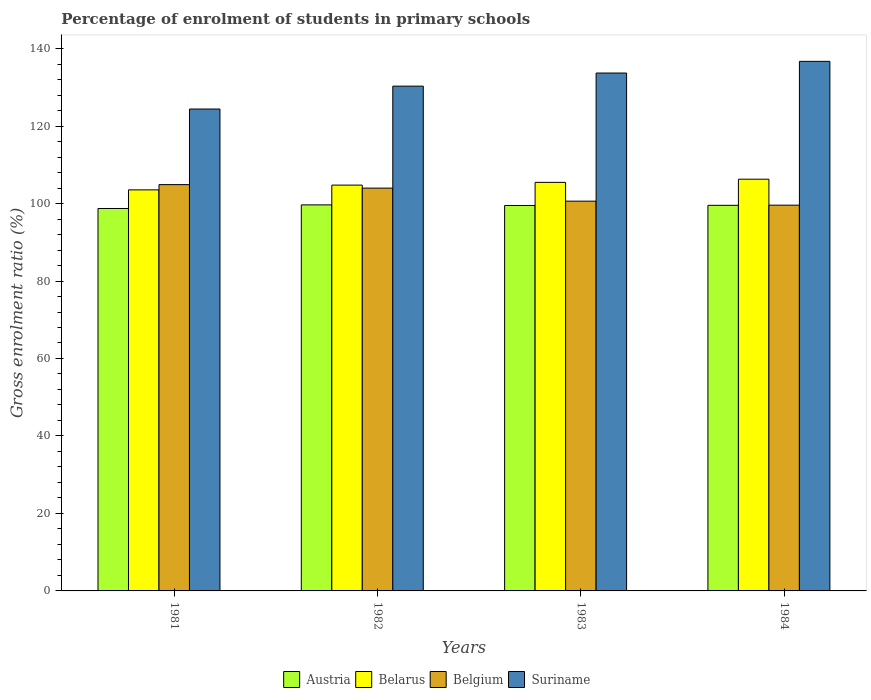How many groups of bars are there?
Your answer should be very brief. 4. Are the number of bars per tick equal to the number of legend labels?
Keep it short and to the point. Yes. How many bars are there on the 4th tick from the right?
Offer a very short reply. 4. In how many cases, is the number of bars for a given year not equal to the number of legend labels?
Your answer should be compact. 0. What is the percentage of students enrolled in primary schools in Austria in 1982?
Offer a very short reply. 99.66. Across all years, what is the maximum percentage of students enrolled in primary schools in Austria?
Make the answer very short. 99.66. Across all years, what is the minimum percentage of students enrolled in primary schools in Austria?
Offer a very short reply. 98.72. In which year was the percentage of students enrolled in primary schools in Austria minimum?
Provide a succinct answer. 1981. What is the total percentage of students enrolled in primary schools in Suriname in the graph?
Give a very brief answer. 525.09. What is the difference between the percentage of students enrolled in primary schools in Belarus in 1983 and that in 1984?
Your answer should be compact. -0.82. What is the difference between the percentage of students enrolled in primary schools in Belarus in 1982 and the percentage of students enrolled in primary schools in Austria in 1984?
Give a very brief answer. 5.22. What is the average percentage of students enrolled in primary schools in Suriname per year?
Provide a succinct answer. 131.27. In the year 1982, what is the difference between the percentage of students enrolled in primary schools in Austria and percentage of students enrolled in primary schools in Belgium?
Provide a succinct answer. -4.33. What is the ratio of the percentage of students enrolled in primary schools in Suriname in 1981 to that in 1983?
Provide a succinct answer. 0.93. Is the percentage of students enrolled in primary schools in Suriname in 1981 less than that in 1984?
Your answer should be very brief. Yes. What is the difference between the highest and the second highest percentage of students enrolled in primary schools in Suriname?
Provide a short and direct response. 3.02. What is the difference between the highest and the lowest percentage of students enrolled in primary schools in Belarus?
Your answer should be compact. 2.75. What does the 3rd bar from the right in 1981 represents?
Keep it short and to the point. Belarus. How many bars are there?
Make the answer very short. 16. How many years are there in the graph?
Provide a short and direct response. 4. Are the values on the major ticks of Y-axis written in scientific E-notation?
Provide a short and direct response. No. Does the graph contain any zero values?
Offer a terse response. No. Does the graph contain grids?
Offer a terse response. No. Where does the legend appear in the graph?
Ensure brevity in your answer.  Bottom center. How are the legend labels stacked?
Offer a terse response. Horizontal. What is the title of the graph?
Provide a short and direct response. Percentage of enrolment of students in primary schools. What is the Gross enrolment ratio (%) in Austria in 1981?
Your response must be concise. 98.72. What is the Gross enrolment ratio (%) in Belarus in 1981?
Give a very brief answer. 103.53. What is the Gross enrolment ratio (%) in Belgium in 1981?
Ensure brevity in your answer.  104.88. What is the Gross enrolment ratio (%) of Suriname in 1981?
Keep it short and to the point. 124.4. What is the Gross enrolment ratio (%) in Austria in 1982?
Keep it short and to the point. 99.66. What is the Gross enrolment ratio (%) of Belarus in 1982?
Make the answer very short. 104.76. What is the Gross enrolment ratio (%) of Belgium in 1982?
Your answer should be very brief. 103.98. What is the Gross enrolment ratio (%) in Suriname in 1982?
Ensure brevity in your answer.  130.31. What is the Gross enrolment ratio (%) of Austria in 1983?
Your answer should be very brief. 99.5. What is the Gross enrolment ratio (%) of Belarus in 1983?
Provide a short and direct response. 105.46. What is the Gross enrolment ratio (%) in Belgium in 1983?
Offer a terse response. 100.61. What is the Gross enrolment ratio (%) of Suriname in 1983?
Offer a very short reply. 133.69. What is the Gross enrolment ratio (%) of Austria in 1984?
Keep it short and to the point. 99.54. What is the Gross enrolment ratio (%) of Belarus in 1984?
Provide a short and direct response. 106.28. What is the Gross enrolment ratio (%) in Belgium in 1984?
Your answer should be very brief. 99.58. What is the Gross enrolment ratio (%) in Suriname in 1984?
Provide a short and direct response. 136.7. Across all years, what is the maximum Gross enrolment ratio (%) of Austria?
Offer a very short reply. 99.66. Across all years, what is the maximum Gross enrolment ratio (%) of Belarus?
Your response must be concise. 106.28. Across all years, what is the maximum Gross enrolment ratio (%) of Belgium?
Your answer should be very brief. 104.88. Across all years, what is the maximum Gross enrolment ratio (%) of Suriname?
Keep it short and to the point. 136.7. Across all years, what is the minimum Gross enrolment ratio (%) in Austria?
Your answer should be compact. 98.72. Across all years, what is the minimum Gross enrolment ratio (%) in Belarus?
Your answer should be very brief. 103.53. Across all years, what is the minimum Gross enrolment ratio (%) of Belgium?
Ensure brevity in your answer.  99.58. Across all years, what is the minimum Gross enrolment ratio (%) of Suriname?
Your answer should be compact. 124.4. What is the total Gross enrolment ratio (%) of Austria in the graph?
Ensure brevity in your answer.  397.41. What is the total Gross enrolment ratio (%) of Belarus in the graph?
Your answer should be very brief. 420.04. What is the total Gross enrolment ratio (%) in Belgium in the graph?
Give a very brief answer. 409.05. What is the total Gross enrolment ratio (%) of Suriname in the graph?
Keep it short and to the point. 525.09. What is the difference between the Gross enrolment ratio (%) of Austria in 1981 and that in 1982?
Provide a short and direct response. -0.93. What is the difference between the Gross enrolment ratio (%) in Belarus in 1981 and that in 1982?
Ensure brevity in your answer.  -1.23. What is the difference between the Gross enrolment ratio (%) in Belgium in 1981 and that in 1982?
Your answer should be very brief. 0.9. What is the difference between the Gross enrolment ratio (%) in Suriname in 1981 and that in 1982?
Ensure brevity in your answer.  -5.91. What is the difference between the Gross enrolment ratio (%) in Austria in 1981 and that in 1983?
Your answer should be very brief. -0.78. What is the difference between the Gross enrolment ratio (%) of Belarus in 1981 and that in 1983?
Provide a succinct answer. -1.94. What is the difference between the Gross enrolment ratio (%) of Belgium in 1981 and that in 1983?
Your answer should be very brief. 4.27. What is the difference between the Gross enrolment ratio (%) of Suriname in 1981 and that in 1983?
Keep it short and to the point. -9.29. What is the difference between the Gross enrolment ratio (%) in Austria in 1981 and that in 1984?
Offer a very short reply. -0.82. What is the difference between the Gross enrolment ratio (%) of Belarus in 1981 and that in 1984?
Offer a terse response. -2.75. What is the difference between the Gross enrolment ratio (%) of Belgium in 1981 and that in 1984?
Make the answer very short. 5.31. What is the difference between the Gross enrolment ratio (%) in Suriname in 1981 and that in 1984?
Offer a very short reply. -12.3. What is the difference between the Gross enrolment ratio (%) in Austria in 1982 and that in 1983?
Keep it short and to the point. 0.16. What is the difference between the Gross enrolment ratio (%) in Belarus in 1982 and that in 1983?
Your answer should be very brief. -0.71. What is the difference between the Gross enrolment ratio (%) of Belgium in 1982 and that in 1983?
Offer a terse response. 3.37. What is the difference between the Gross enrolment ratio (%) of Suriname in 1982 and that in 1983?
Provide a short and direct response. -3.38. What is the difference between the Gross enrolment ratio (%) in Austria in 1982 and that in 1984?
Ensure brevity in your answer.  0.12. What is the difference between the Gross enrolment ratio (%) in Belarus in 1982 and that in 1984?
Your response must be concise. -1.52. What is the difference between the Gross enrolment ratio (%) of Belgium in 1982 and that in 1984?
Offer a terse response. 4.4. What is the difference between the Gross enrolment ratio (%) of Suriname in 1982 and that in 1984?
Offer a very short reply. -6.4. What is the difference between the Gross enrolment ratio (%) in Austria in 1983 and that in 1984?
Provide a short and direct response. -0.04. What is the difference between the Gross enrolment ratio (%) of Belarus in 1983 and that in 1984?
Your answer should be compact. -0.82. What is the difference between the Gross enrolment ratio (%) in Belgium in 1983 and that in 1984?
Provide a short and direct response. 1.03. What is the difference between the Gross enrolment ratio (%) of Suriname in 1983 and that in 1984?
Offer a terse response. -3.02. What is the difference between the Gross enrolment ratio (%) in Austria in 1981 and the Gross enrolment ratio (%) in Belarus in 1982?
Make the answer very short. -6.04. What is the difference between the Gross enrolment ratio (%) in Austria in 1981 and the Gross enrolment ratio (%) in Belgium in 1982?
Keep it short and to the point. -5.26. What is the difference between the Gross enrolment ratio (%) in Austria in 1981 and the Gross enrolment ratio (%) in Suriname in 1982?
Give a very brief answer. -31.59. What is the difference between the Gross enrolment ratio (%) in Belarus in 1981 and the Gross enrolment ratio (%) in Belgium in 1982?
Provide a short and direct response. -0.45. What is the difference between the Gross enrolment ratio (%) in Belarus in 1981 and the Gross enrolment ratio (%) in Suriname in 1982?
Keep it short and to the point. -26.78. What is the difference between the Gross enrolment ratio (%) in Belgium in 1981 and the Gross enrolment ratio (%) in Suriname in 1982?
Offer a very short reply. -25.42. What is the difference between the Gross enrolment ratio (%) of Austria in 1981 and the Gross enrolment ratio (%) of Belarus in 1983?
Provide a short and direct response. -6.74. What is the difference between the Gross enrolment ratio (%) in Austria in 1981 and the Gross enrolment ratio (%) in Belgium in 1983?
Your answer should be very brief. -1.89. What is the difference between the Gross enrolment ratio (%) of Austria in 1981 and the Gross enrolment ratio (%) of Suriname in 1983?
Provide a short and direct response. -34.96. What is the difference between the Gross enrolment ratio (%) in Belarus in 1981 and the Gross enrolment ratio (%) in Belgium in 1983?
Your answer should be compact. 2.92. What is the difference between the Gross enrolment ratio (%) in Belarus in 1981 and the Gross enrolment ratio (%) in Suriname in 1983?
Your response must be concise. -30.16. What is the difference between the Gross enrolment ratio (%) of Belgium in 1981 and the Gross enrolment ratio (%) of Suriname in 1983?
Provide a short and direct response. -28.8. What is the difference between the Gross enrolment ratio (%) of Austria in 1981 and the Gross enrolment ratio (%) of Belarus in 1984?
Offer a terse response. -7.56. What is the difference between the Gross enrolment ratio (%) in Austria in 1981 and the Gross enrolment ratio (%) in Belgium in 1984?
Ensure brevity in your answer.  -0.86. What is the difference between the Gross enrolment ratio (%) of Austria in 1981 and the Gross enrolment ratio (%) of Suriname in 1984?
Ensure brevity in your answer.  -37.98. What is the difference between the Gross enrolment ratio (%) of Belarus in 1981 and the Gross enrolment ratio (%) of Belgium in 1984?
Keep it short and to the point. 3.95. What is the difference between the Gross enrolment ratio (%) in Belarus in 1981 and the Gross enrolment ratio (%) in Suriname in 1984?
Ensure brevity in your answer.  -33.17. What is the difference between the Gross enrolment ratio (%) of Belgium in 1981 and the Gross enrolment ratio (%) of Suriname in 1984?
Your answer should be compact. -31.82. What is the difference between the Gross enrolment ratio (%) in Austria in 1982 and the Gross enrolment ratio (%) in Belarus in 1983?
Make the answer very short. -5.81. What is the difference between the Gross enrolment ratio (%) of Austria in 1982 and the Gross enrolment ratio (%) of Belgium in 1983?
Your answer should be compact. -0.96. What is the difference between the Gross enrolment ratio (%) in Austria in 1982 and the Gross enrolment ratio (%) in Suriname in 1983?
Provide a succinct answer. -34.03. What is the difference between the Gross enrolment ratio (%) of Belarus in 1982 and the Gross enrolment ratio (%) of Belgium in 1983?
Offer a terse response. 4.15. What is the difference between the Gross enrolment ratio (%) in Belarus in 1982 and the Gross enrolment ratio (%) in Suriname in 1983?
Offer a very short reply. -28.93. What is the difference between the Gross enrolment ratio (%) of Belgium in 1982 and the Gross enrolment ratio (%) of Suriname in 1983?
Give a very brief answer. -29.7. What is the difference between the Gross enrolment ratio (%) of Austria in 1982 and the Gross enrolment ratio (%) of Belarus in 1984?
Ensure brevity in your answer.  -6.63. What is the difference between the Gross enrolment ratio (%) in Austria in 1982 and the Gross enrolment ratio (%) in Belgium in 1984?
Keep it short and to the point. 0.08. What is the difference between the Gross enrolment ratio (%) of Austria in 1982 and the Gross enrolment ratio (%) of Suriname in 1984?
Provide a short and direct response. -37.05. What is the difference between the Gross enrolment ratio (%) of Belarus in 1982 and the Gross enrolment ratio (%) of Belgium in 1984?
Offer a terse response. 5.18. What is the difference between the Gross enrolment ratio (%) in Belarus in 1982 and the Gross enrolment ratio (%) in Suriname in 1984?
Offer a terse response. -31.94. What is the difference between the Gross enrolment ratio (%) in Belgium in 1982 and the Gross enrolment ratio (%) in Suriname in 1984?
Your response must be concise. -32.72. What is the difference between the Gross enrolment ratio (%) of Austria in 1983 and the Gross enrolment ratio (%) of Belarus in 1984?
Provide a succinct answer. -6.79. What is the difference between the Gross enrolment ratio (%) in Austria in 1983 and the Gross enrolment ratio (%) in Belgium in 1984?
Offer a terse response. -0.08. What is the difference between the Gross enrolment ratio (%) in Austria in 1983 and the Gross enrolment ratio (%) in Suriname in 1984?
Your answer should be very brief. -37.21. What is the difference between the Gross enrolment ratio (%) of Belarus in 1983 and the Gross enrolment ratio (%) of Belgium in 1984?
Offer a very short reply. 5.89. What is the difference between the Gross enrolment ratio (%) in Belarus in 1983 and the Gross enrolment ratio (%) in Suriname in 1984?
Your answer should be compact. -31.24. What is the difference between the Gross enrolment ratio (%) in Belgium in 1983 and the Gross enrolment ratio (%) in Suriname in 1984?
Provide a short and direct response. -36.09. What is the average Gross enrolment ratio (%) in Austria per year?
Ensure brevity in your answer.  99.35. What is the average Gross enrolment ratio (%) of Belarus per year?
Your response must be concise. 105.01. What is the average Gross enrolment ratio (%) in Belgium per year?
Make the answer very short. 102.26. What is the average Gross enrolment ratio (%) of Suriname per year?
Offer a very short reply. 131.27. In the year 1981, what is the difference between the Gross enrolment ratio (%) of Austria and Gross enrolment ratio (%) of Belarus?
Keep it short and to the point. -4.81. In the year 1981, what is the difference between the Gross enrolment ratio (%) in Austria and Gross enrolment ratio (%) in Belgium?
Keep it short and to the point. -6.16. In the year 1981, what is the difference between the Gross enrolment ratio (%) in Austria and Gross enrolment ratio (%) in Suriname?
Provide a succinct answer. -25.68. In the year 1981, what is the difference between the Gross enrolment ratio (%) in Belarus and Gross enrolment ratio (%) in Belgium?
Give a very brief answer. -1.35. In the year 1981, what is the difference between the Gross enrolment ratio (%) in Belarus and Gross enrolment ratio (%) in Suriname?
Keep it short and to the point. -20.87. In the year 1981, what is the difference between the Gross enrolment ratio (%) of Belgium and Gross enrolment ratio (%) of Suriname?
Keep it short and to the point. -19.51. In the year 1982, what is the difference between the Gross enrolment ratio (%) in Austria and Gross enrolment ratio (%) in Belarus?
Offer a very short reply. -5.1. In the year 1982, what is the difference between the Gross enrolment ratio (%) in Austria and Gross enrolment ratio (%) in Belgium?
Provide a succinct answer. -4.33. In the year 1982, what is the difference between the Gross enrolment ratio (%) in Austria and Gross enrolment ratio (%) in Suriname?
Provide a succinct answer. -30.65. In the year 1982, what is the difference between the Gross enrolment ratio (%) in Belarus and Gross enrolment ratio (%) in Belgium?
Provide a short and direct response. 0.78. In the year 1982, what is the difference between the Gross enrolment ratio (%) in Belarus and Gross enrolment ratio (%) in Suriname?
Provide a short and direct response. -25.55. In the year 1982, what is the difference between the Gross enrolment ratio (%) in Belgium and Gross enrolment ratio (%) in Suriname?
Ensure brevity in your answer.  -26.33. In the year 1983, what is the difference between the Gross enrolment ratio (%) of Austria and Gross enrolment ratio (%) of Belarus?
Offer a very short reply. -5.97. In the year 1983, what is the difference between the Gross enrolment ratio (%) of Austria and Gross enrolment ratio (%) of Belgium?
Offer a very short reply. -1.11. In the year 1983, what is the difference between the Gross enrolment ratio (%) in Austria and Gross enrolment ratio (%) in Suriname?
Your answer should be very brief. -34.19. In the year 1983, what is the difference between the Gross enrolment ratio (%) in Belarus and Gross enrolment ratio (%) in Belgium?
Offer a very short reply. 4.85. In the year 1983, what is the difference between the Gross enrolment ratio (%) of Belarus and Gross enrolment ratio (%) of Suriname?
Provide a succinct answer. -28.22. In the year 1983, what is the difference between the Gross enrolment ratio (%) in Belgium and Gross enrolment ratio (%) in Suriname?
Give a very brief answer. -33.07. In the year 1984, what is the difference between the Gross enrolment ratio (%) in Austria and Gross enrolment ratio (%) in Belarus?
Offer a terse response. -6.74. In the year 1984, what is the difference between the Gross enrolment ratio (%) of Austria and Gross enrolment ratio (%) of Belgium?
Offer a very short reply. -0.04. In the year 1984, what is the difference between the Gross enrolment ratio (%) in Austria and Gross enrolment ratio (%) in Suriname?
Provide a succinct answer. -37.16. In the year 1984, what is the difference between the Gross enrolment ratio (%) of Belarus and Gross enrolment ratio (%) of Belgium?
Provide a short and direct response. 6.71. In the year 1984, what is the difference between the Gross enrolment ratio (%) of Belarus and Gross enrolment ratio (%) of Suriname?
Your response must be concise. -30.42. In the year 1984, what is the difference between the Gross enrolment ratio (%) in Belgium and Gross enrolment ratio (%) in Suriname?
Ensure brevity in your answer.  -37.12. What is the ratio of the Gross enrolment ratio (%) in Austria in 1981 to that in 1982?
Provide a short and direct response. 0.99. What is the ratio of the Gross enrolment ratio (%) in Belarus in 1981 to that in 1982?
Provide a succinct answer. 0.99. What is the ratio of the Gross enrolment ratio (%) in Belgium in 1981 to that in 1982?
Provide a short and direct response. 1.01. What is the ratio of the Gross enrolment ratio (%) of Suriname in 1981 to that in 1982?
Make the answer very short. 0.95. What is the ratio of the Gross enrolment ratio (%) of Austria in 1981 to that in 1983?
Your answer should be very brief. 0.99. What is the ratio of the Gross enrolment ratio (%) of Belarus in 1981 to that in 1983?
Ensure brevity in your answer.  0.98. What is the ratio of the Gross enrolment ratio (%) in Belgium in 1981 to that in 1983?
Offer a very short reply. 1.04. What is the ratio of the Gross enrolment ratio (%) in Suriname in 1981 to that in 1983?
Your response must be concise. 0.93. What is the ratio of the Gross enrolment ratio (%) of Belarus in 1981 to that in 1984?
Offer a very short reply. 0.97. What is the ratio of the Gross enrolment ratio (%) of Belgium in 1981 to that in 1984?
Offer a terse response. 1.05. What is the ratio of the Gross enrolment ratio (%) in Suriname in 1981 to that in 1984?
Your response must be concise. 0.91. What is the ratio of the Gross enrolment ratio (%) in Belgium in 1982 to that in 1983?
Ensure brevity in your answer.  1.03. What is the ratio of the Gross enrolment ratio (%) in Suriname in 1982 to that in 1983?
Provide a short and direct response. 0.97. What is the ratio of the Gross enrolment ratio (%) in Belarus in 1982 to that in 1984?
Make the answer very short. 0.99. What is the ratio of the Gross enrolment ratio (%) of Belgium in 1982 to that in 1984?
Keep it short and to the point. 1.04. What is the ratio of the Gross enrolment ratio (%) of Suriname in 1982 to that in 1984?
Give a very brief answer. 0.95. What is the ratio of the Gross enrolment ratio (%) in Belarus in 1983 to that in 1984?
Ensure brevity in your answer.  0.99. What is the ratio of the Gross enrolment ratio (%) of Belgium in 1983 to that in 1984?
Make the answer very short. 1.01. What is the ratio of the Gross enrolment ratio (%) in Suriname in 1983 to that in 1984?
Your answer should be compact. 0.98. What is the difference between the highest and the second highest Gross enrolment ratio (%) of Austria?
Ensure brevity in your answer.  0.12. What is the difference between the highest and the second highest Gross enrolment ratio (%) of Belarus?
Offer a terse response. 0.82. What is the difference between the highest and the second highest Gross enrolment ratio (%) in Belgium?
Ensure brevity in your answer.  0.9. What is the difference between the highest and the second highest Gross enrolment ratio (%) in Suriname?
Your response must be concise. 3.02. What is the difference between the highest and the lowest Gross enrolment ratio (%) of Austria?
Make the answer very short. 0.93. What is the difference between the highest and the lowest Gross enrolment ratio (%) in Belarus?
Your answer should be compact. 2.75. What is the difference between the highest and the lowest Gross enrolment ratio (%) in Belgium?
Your answer should be compact. 5.31. What is the difference between the highest and the lowest Gross enrolment ratio (%) in Suriname?
Give a very brief answer. 12.3. 